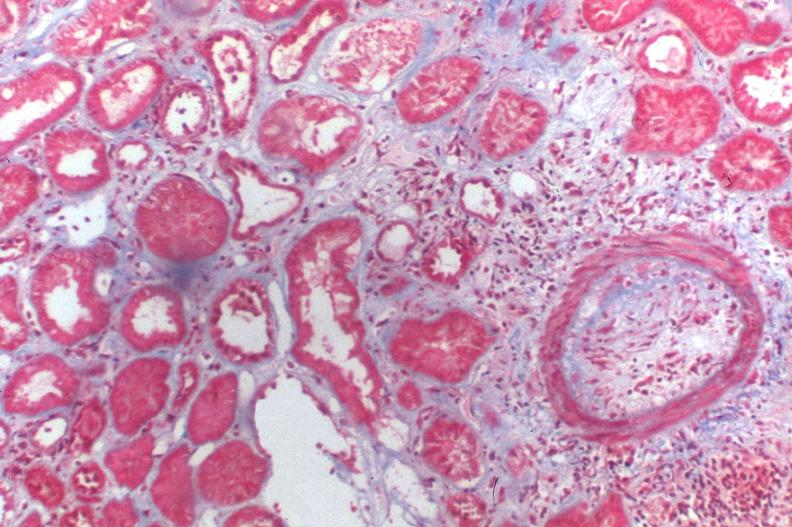does this image show kidney transplant rejection?
Answer the question using a single word or phrase. Yes 